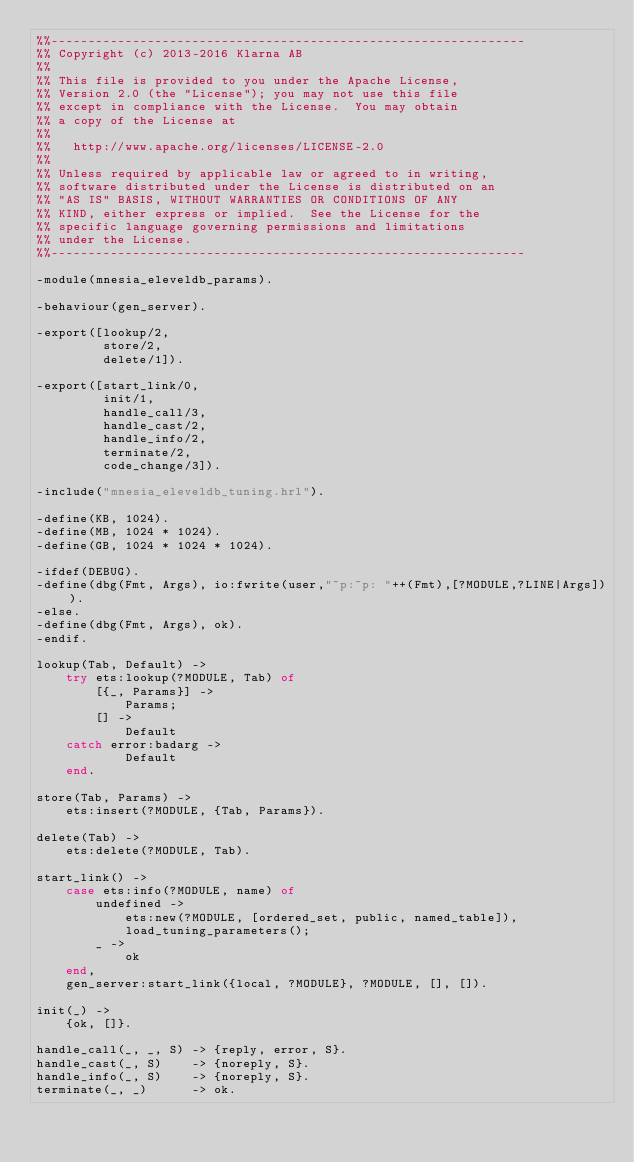Convert code to text. <code><loc_0><loc_0><loc_500><loc_500><_Erlang_>%%----------------------------------------------------------------
%% Copyright (c) 2013-2016 Klarna AB
%%
%% This file is provided to you under the Apache License,
%% Version 2.0 (the "License"); you may not use this file
%% except in compliance with the License.  You may obtain
%% a copy of the License at
%%
%%   http://www.apache.org/licenses/LICENSE-2.0
%%
%% Unless required by applicable law or agreed to in writing,
%% software distributed under the License is distributed on an
%% "AS IS" BASIS, WITHOUT WARRANTIES OR CONDITIONS OF ANY
%% KIND, either express or implied.  See the License for the
%% specific language governing permissions and limitations
%% under the License.
%%----------------------------------------------------------------

-module(mnesia_eleveldb_params).

-behaviour(gen_server).

-export([lookup/2,
         store/2,
         delete/1]).

-export([start_link/0,
         init/1,
         handle_call/3,
         handle_cast/2,
         handle_info/2,
         terminate/2,
         code_change/3]).

-include("mnesia_eleveldb_tuning.hrl").

-define(KB, 1024).
-define(MB, 1024 * 1024).
-define(GB, 1024 * 1024 * 1024).

-ifdef(DEBUG).
-define(dbg(Fmt, Args), io:fwrite(user,"~p:~p: "++(Fmt),[?MODULE,?LINE|Args])).
-else.
-define(dbg(Fmt, Args), ok).
-endif.

lookup(Tab, Default) ->
    try ets:lookup(?MODULE, Tab) of
        [{_, Params}] ->
            Params;
        [] ->
            Default
    catch error:badarg ->
            Default
    end.

store(Tab, Params) ->
    ets:insert(?MODULE, {Tab, Params}).

delete(Tab) ->
    ets:delete(?MODULE, Tab).

start_link() ->
    case ets:info(?MODULE, name) of
        undefined ->
            ets:new(?MODULE, [ordered_set, public, named_table]),
            load_tuning_parameters();
        _ ->
            ok
    end,
    gen_server:start_link({local, ?MODULE}, ?MODULE, [], []).

init(_) ->
    {ok, []}.

handle_call(_, _, S) -> {reply, error, S}.
handle_cast(_, S)    -> {noreply, S}.
handle_info(_, S)    -> {noreply, S}.
terminate(_, _)      -> ok.</code> 